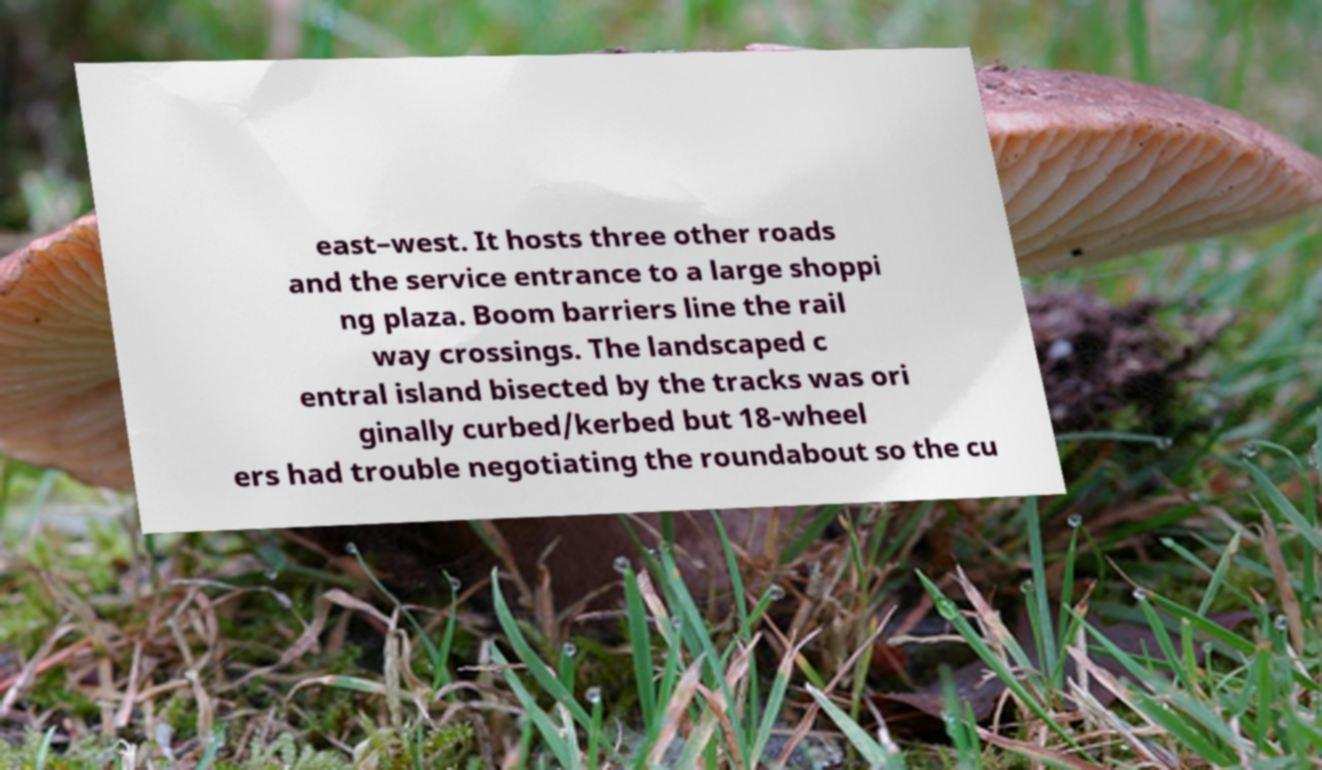Could you extract and type out the text from this image? east–west. It hosts three other roads and the service entrance to a large shoppi ng plaza. Boom barriers line the rail way crossings. The landscaped c entral island bisected by the tracks was ori ginally curbed/kerbed but 18-wheel ers had trouble negotiating the roundabout so the cu 